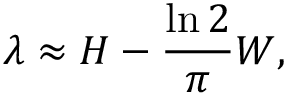<formula> <loc_0><loc_0><loc_500><loc_500>\lambda \approx H - \frac { \ln 2 } { \pi } W ,</formula> 